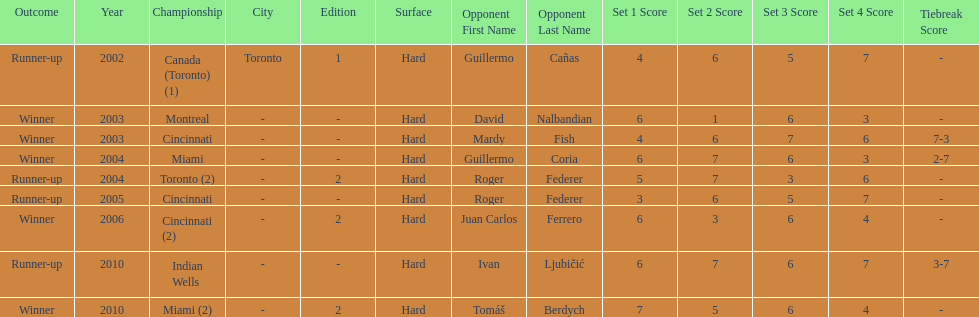How many times was the championship in miami? 2. 